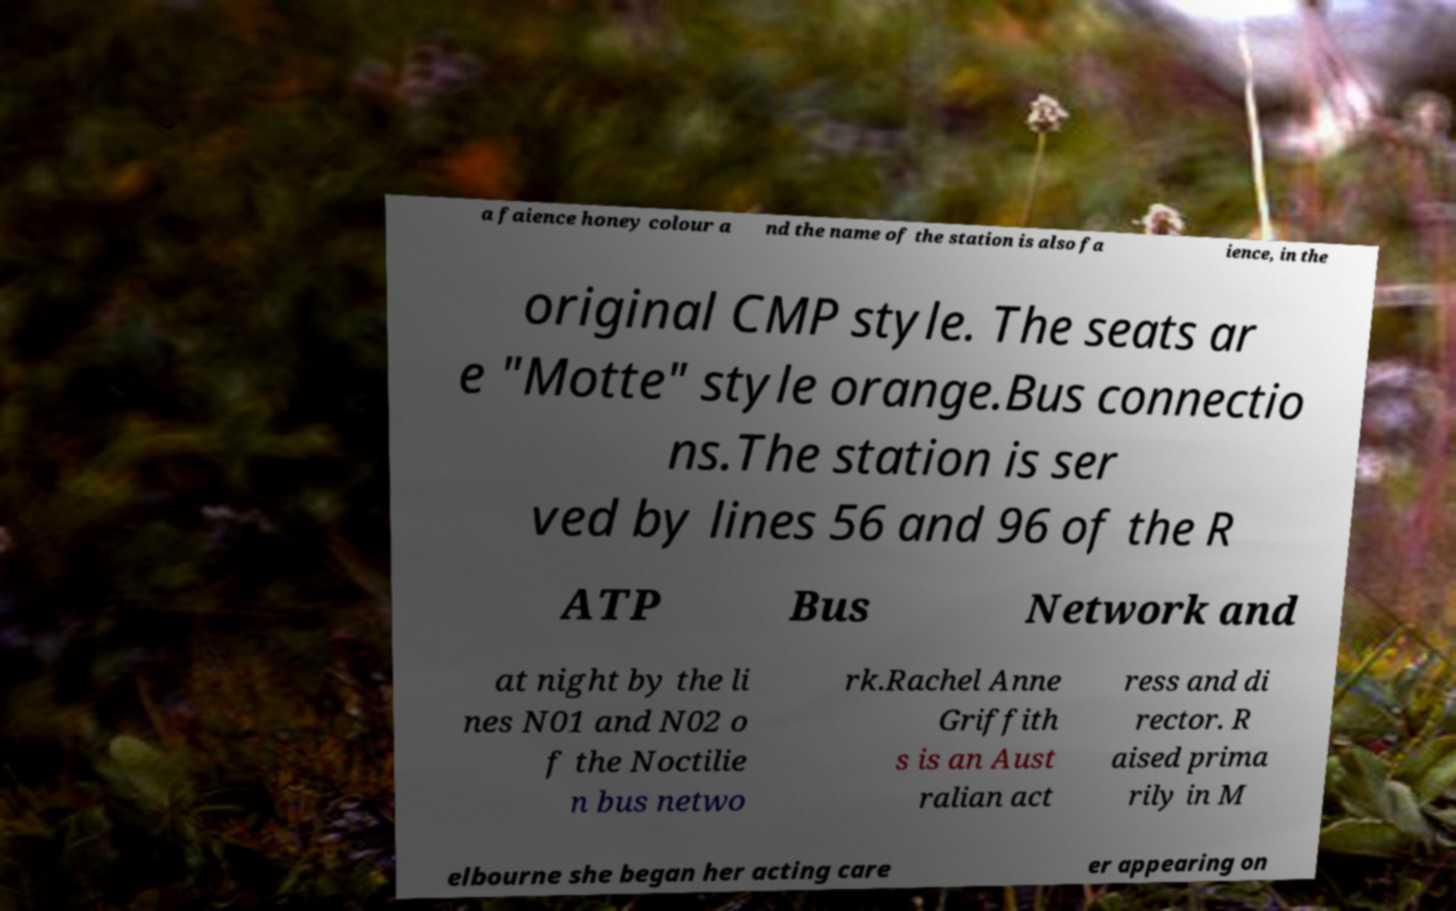Can you read and provide the text displayed in the image?This photo seems to have some interesting text. Can you extract and type it out for me? a faience honey colour a nd the name of the station is also fa ience, in the original CMP style. The seats ar e "Motte" style orange.Bus connectio ns.The station is ser ved by lines 56 and 96 of the R ATP Bus Network and at night by the li nes N01 and N02 o f the Noctilie n bus netwo rk.Rachel Anne Griffith s is an Aust ralian act ress and di rector. R aised prima rily in M elbourne she began her acting care er appearing on 